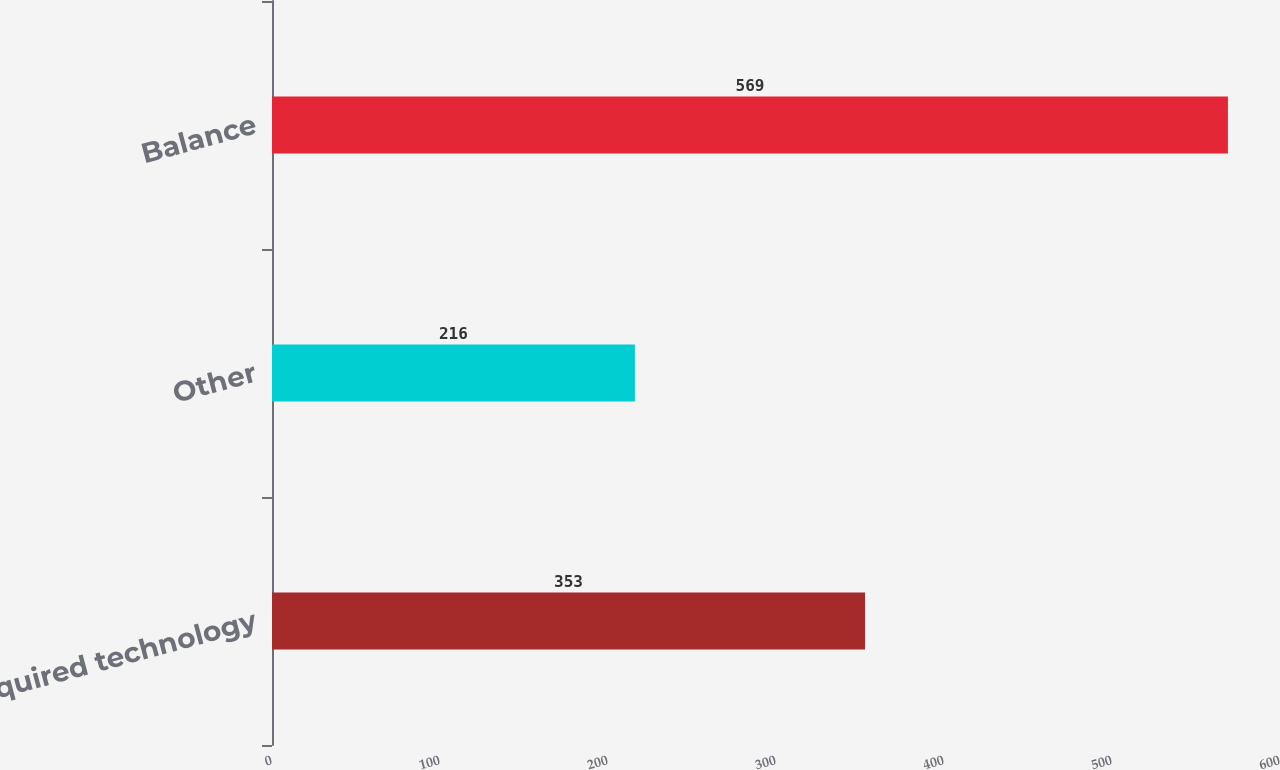Convert chart to OTSL. <chart><loc_0><loc_0><loc_500><loc_500><bar_chart><fcel>Acquired technology<fcel>Other<fcel>Balance<nl><fcel>353<fcel>216<fcel>569<nl></chart> 